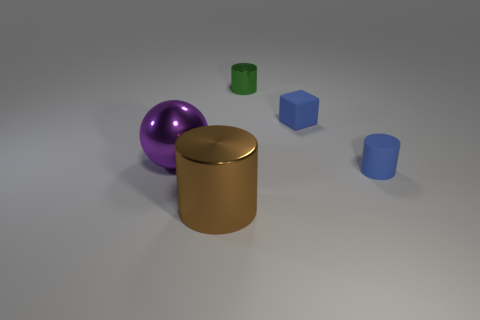Subtract all cyan balls. Subtract all green cylinders. How many balls are left? 1 Add 4 red matte blocks. How many objects exist? 9 Subtract all cylinders. How many objects are left? 2 Add 1 green cylinders. How many green cylinders exist? 2 Subtract 0 green cubes. How many objects are left? 5 Subtract all big purple matte balls. Subtract all big metal objects. How many objects are left? 3 Add 2 brown objects. How many brown objects are left? 3 